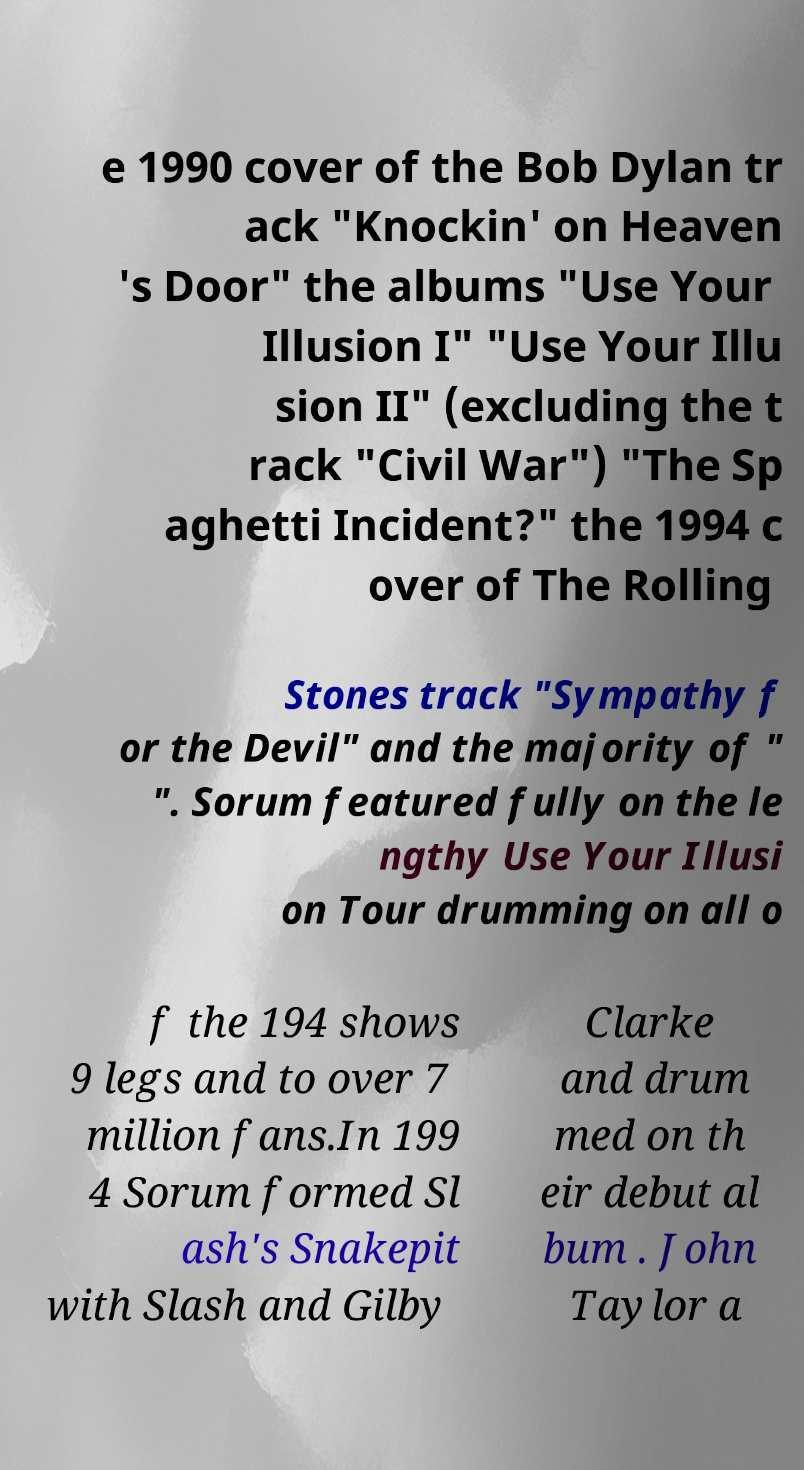Please identify and transcribe the text found in this image. e 1990 cover of the Bob Dylan tr ack "Knockin' on Heaven 's Door" the albums "Use Your Illusion I" "Use Your Illu sion II" (excluding the t rack "Civil War") "The Sp aghetti Incident?" the 1994 c over of The Rolling Stones track "Sympathy f or the Devil" and the majority of " ". Sorum featured fully on the le ngthy Use Your Illusi on Tour drumming on all o f the 194 shows 9 legs and to over 7 million fans.In 199 4 Sorum formed Sl ash's Snakepit with Slash and Gilby Clarke and drum med on th eir debut al bum . John Taylor a 